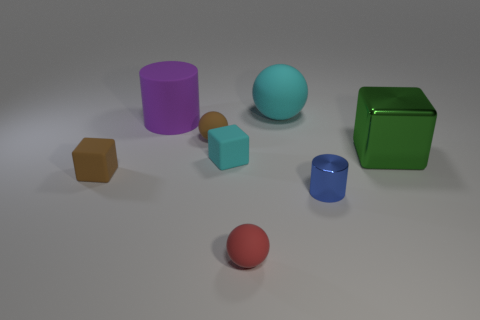Subtract all tiny matte spheres. How many spheres are left? 1 Add 1 brown rubber things. How many objects exist? 9 Subtract 1 spheres. How many spheres are left? 2 Subtract all cylinders. How many objects are left? 6 Subtract all gray balls. Subtract all green cylinders. How many balls are left? 3 Subtract 0 blue blocks. How many objects are left? 8 Subtract all big purple matte spheres. Subtract all tiny rubber balls. How many objects are left? 6 Add 1 red spheres. How many red spheres are left? 2 Add 7 brown rubber things. How many brown rubber things exist? 9 